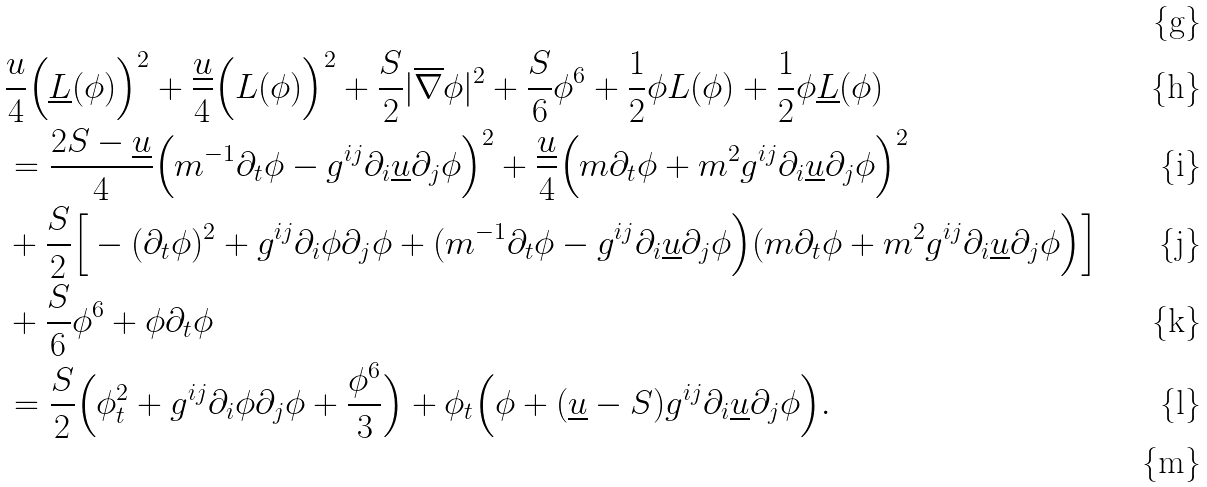<formula> <loc_0><loc_0><loc_500><loc_500>\\ & \frac { u } { 4 } \Big ( \underline { L } ( \phi ) \Big ) ^ { 2 } + \frac { \underline { u } } { 4 } \Big ( L ( \phi ) \Big ) ^ { 2 } + \frac { S } { 2 } | \overline { \nabla } \phi | ^ { 2 } + \frac { S } { 6 } \phi ^ { 6 } + \frac { 1 } { 2 } \phi L ( \phi ) + \frac { 1 } { 2 } \phi \underline { L } ( \phi ) \\ & = \frac { 2 S - \underline { u } } { 4 } \Big ( m ^ { - 1 } \partial _ { t } \phi - g ^ { i j } \partial _ { i } \underline { u } \partial _ { j } \phi \Big ) ^ { 2 } + \frac { \underline { u } } { 4 } \Big ( m \partial _ { t } \phi + m ^ { 2 } g ^ { i j } \partial _ { i } \underline { u } \partial _ { j } \phi \Big ) ^ { 2 } \\ & + \frac { S } { 2 } \Big [ - ( \partial _ { t } \phi ) ^ { 2 } + g ^ { i j } \partial _ { i } \phi \partial _ { j } \phi + ( m ^ { - 1 } \partial _ { t } \phi - g ^ { i j } \partial _ { i } \underline { u } \partial _ { j } \phi \Big ) ( m \partial _ { t } \phi + m ^ { 2 } g ^ { i j } \partial _ { i } \underline { u } \partial _ { j } \phi \Big ) \Big ] \\ & + \frac { S } { 6 } \phi ^ { 6 } + \phi \partial _ { t } \phi \\ & = \frac { S } { 2 } \Big ( \phi _ { t } ^ { 2 } + g ^ { i j } \partial _ { i } \phi \partial _ { j } \phi + \frac { \phi ^ { 6 } } { 3 } \Big ) + \phi _ { t } \Big ( \phi + ( \underline { u } - S ) g ^ { i j } \partial _ { i } \underline { u } \partial _ { j } \phi \Big ) . \\</formula> 